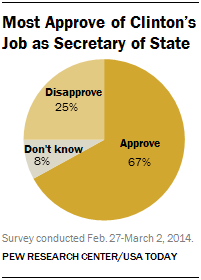Can you tell me the source of this survey? The source of this survey, as noted at the bottom of the image, is the Pew Research Center and USA Today. 